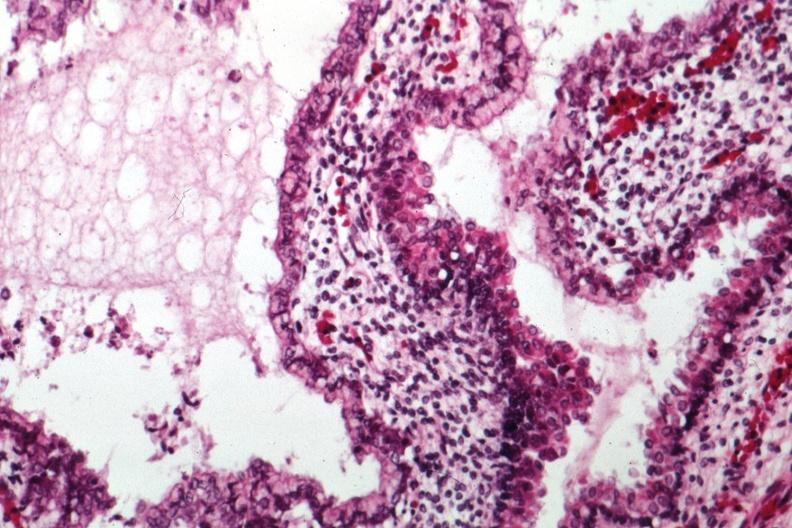what does this image show?
Answer the question using a single word or phrase. Epithelial component like intestine 